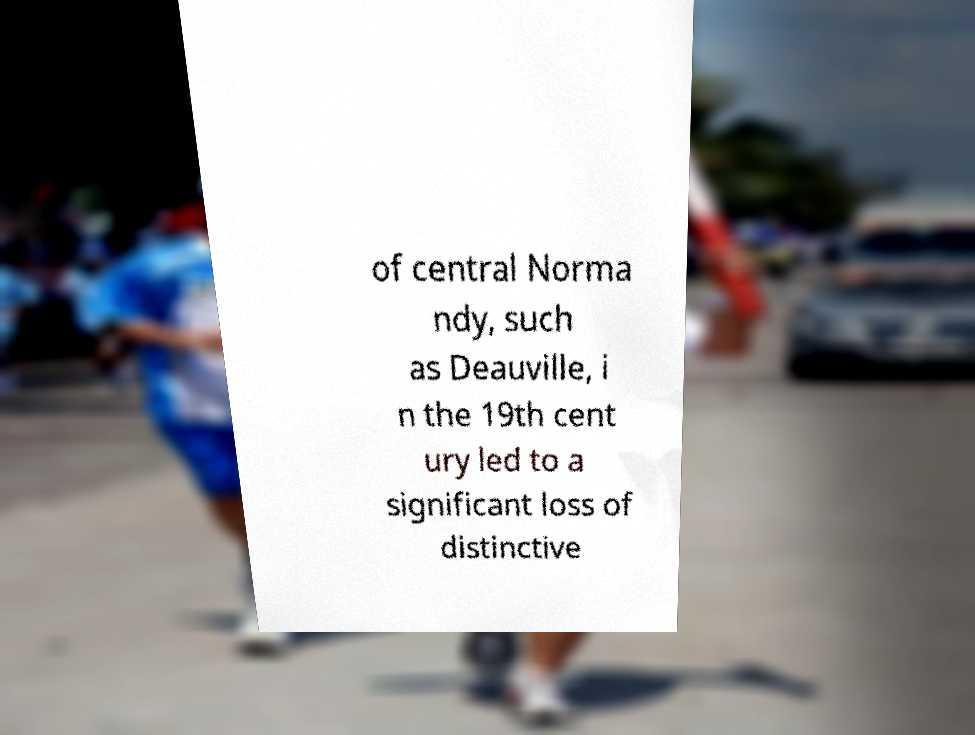Can you accurately transcribe the text from the provided image for me? of central Norma ndy, such as Deauville, i n the 19th cent ury led to a significant loss of distinctive 